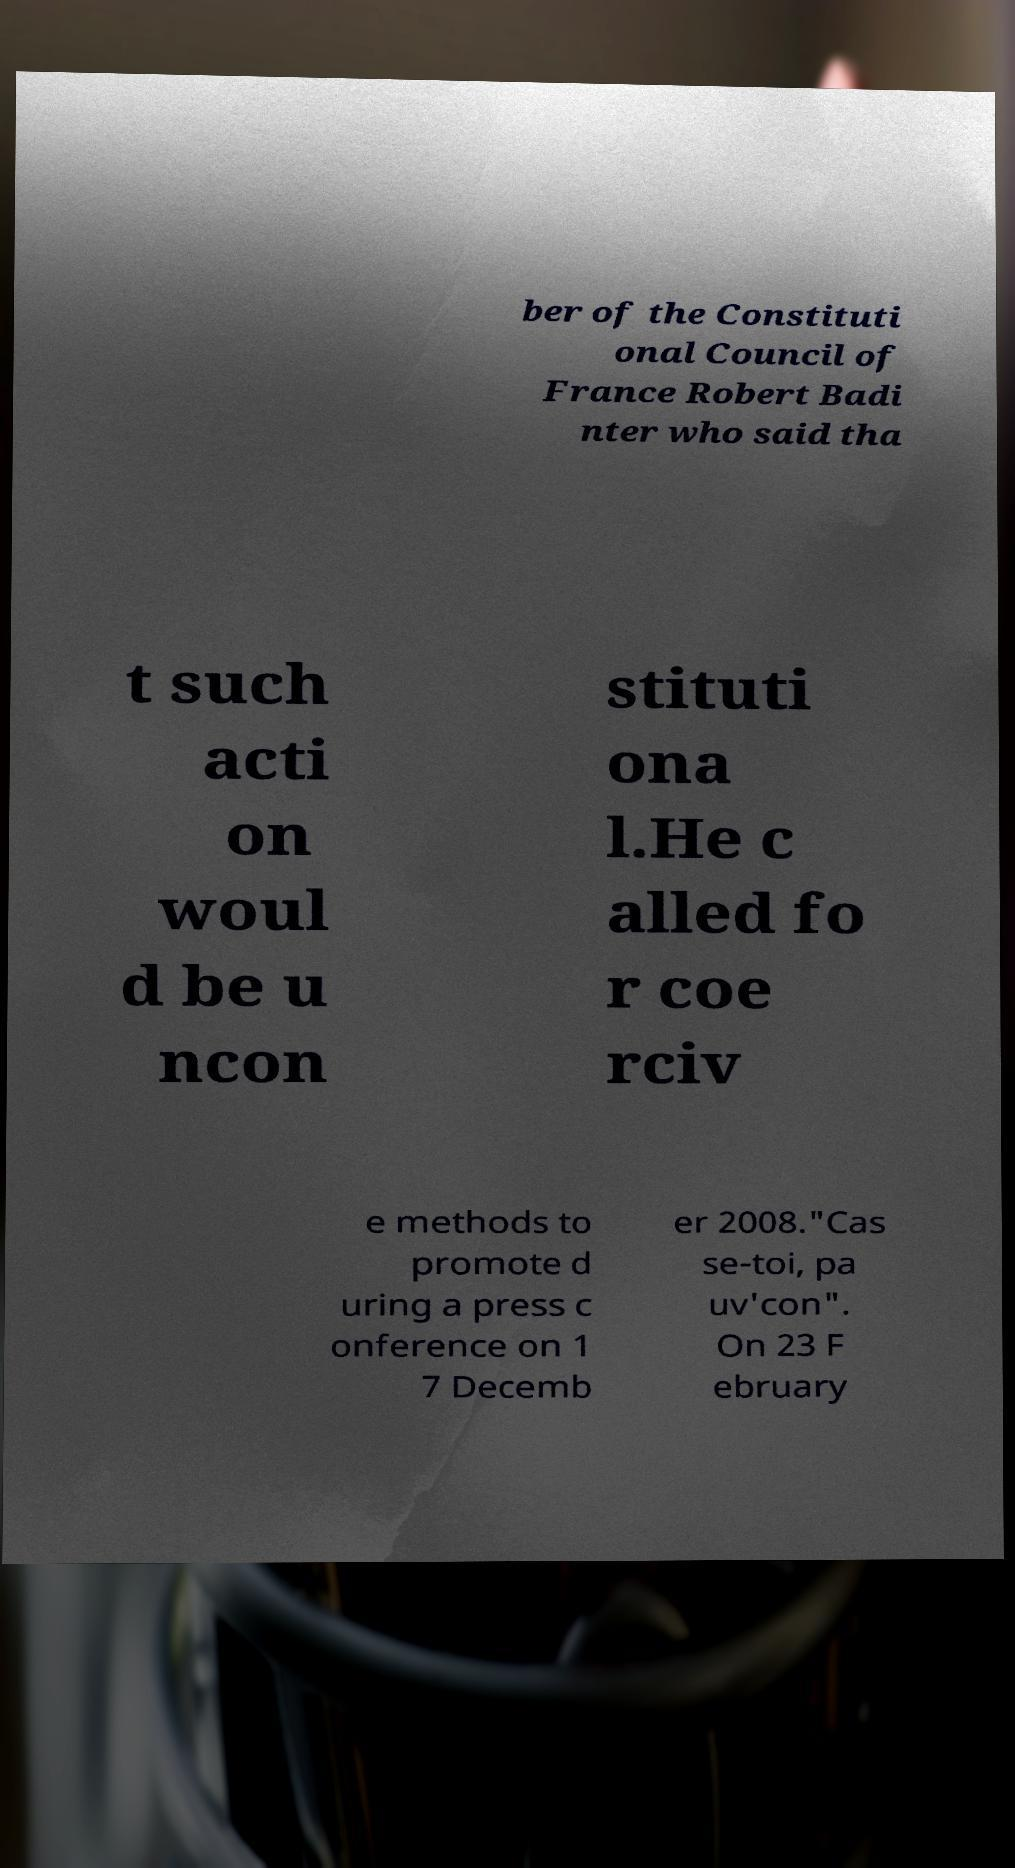I need the written content from this picture converted into text. Can you do that? ber of the Constituti onal Council of France Robert Badi nter who said tha t such acti on woul d be u ncon stituti ona l.He c alled fo r coe rciv e methods to promote d uring a press c onference on 1 7 Decemb er 2008."Cas se-toi, pa uv'con". On 23 F ebruary 